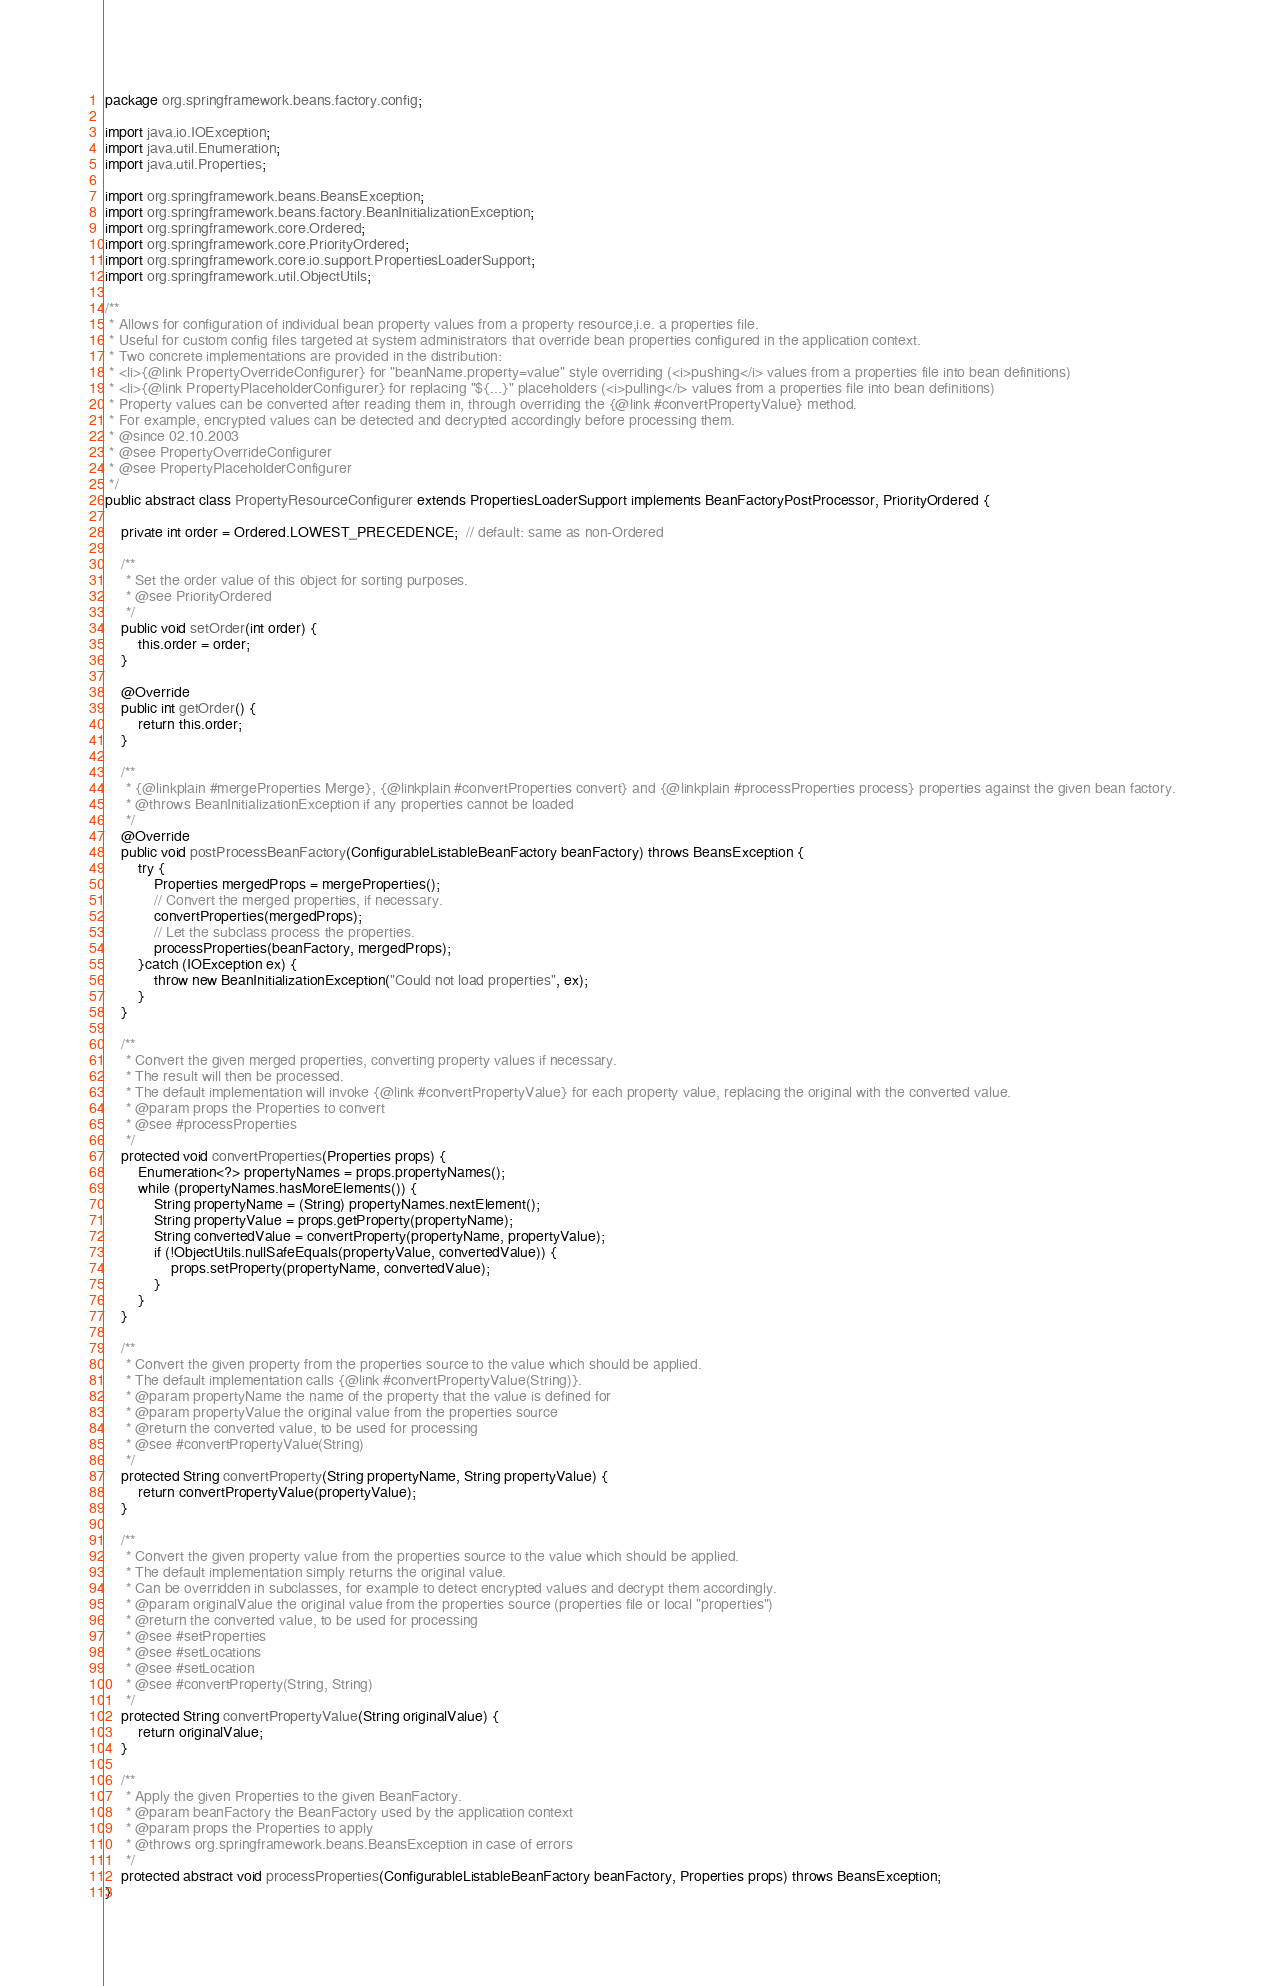Convert code to text. <code><loc_0><loc_0><loc_500><loc_500><_Java_>

package org.springframework.beans.factory.config;

import java.io.IOException;
import java.util.Enumeration;
import java.util.Properties;

import org.springframework.beans.BeansException;
import org.springframework.beans.factory.BeanInitializationException;
import org.springframework.core.Ordered;
import org.springframework.core.PriorityOrdered;
import org.springframework.core.io.support.PropertiesLoaderSupport;
import org.springframework.util.ObjectUtils;

/**
 * Allows for configuration of individual bean property values from a property resource,i.e. a properties file.
 * Useful for custom config files targeted at system administrators that override bean properties configured in the application context.
 * Two concrete implementations are provided in the distribution:
 * <li>{@link PropertyOverrideConfigurer} for "beanName.property=value" style overriding (<i>pushing</i> values from a properties file into bean definitions)
 * <li>{@link PropertyPlaceholderConfigurer} for replacing "${...}" placeholders (<i>pulling</i> values from a properties file into bean definitions)
 * Property values can be converted after reading them in, through overriding the {@link #convertPropertyValue} method.
 * For example, encrypted values can be detected and decrypted accordingly before processing them.
 * @since 02.10.2003
 * @see PropertyOverrideConfigurer
 * @see PropertyPlaceholderConfigurer
 */
public abstract class PropertyResourceConfigurer extends PropertiesLoaderSupport implements BeanFactoryPostProcessor, PriorityOrdered {

	private int order = Ordered.LOWEST_PRECEDENCE;  // default: same as non-Ordered

	/**
	 * Set the order value of this object for sorting purposes.
	 * @see PriorityOrdered
	 */
	public void setOrder(int order) {
		this.order = order;
	}

	@Override
	public int getOrder() {
		return this.order;
	}

	/**
	 * {@linkplain #mergeProperties Merge}, {@linkplain #convertProperties convert} and {@linkplain #processProperties process} properties against the given bean factory.
	 * @throws BeanInitializationException if any properties cannot be loaded
	 */
	@Override
	public void postProcessBeanFactory(ConfigurableListableBeanFactory beanFactory) throws BeansException {
		try {
			Properties mergedProps = mergeProperties();
			// Convert the merged properties, if necessary.
			convertProperties(mergedProps);
			// Let the subclass process the properties.
			processProperties(beanFactory, mergedProps);
		}catch (IOException ex) {
			throw new BeanInitializationException("Could not load properties", ex);
		}
	}

	/**
	 * Convert the given merged properties, converting property values if necessary.
	 * The result will then be processed.
	 * The default implementation will invoke {@link #convertPropertyValue} for each property value, replacing the original with the converted value.
	 * @param props the Properties to convert
	 * @see #processProperties
	 */
	protected void convertProperties(Properties props) {
		Enumeration<?> propertyNames = props.propertyNames();
		while (propertyNames.hasMoreElements()) {
			String propertyName = (String) propertyNames.nextElement();
			String propertyValue = props.getProperty(propertyName);
			String convertedValue = convertProperty(propertyName, propertyValue);
			if (!ObjectUtils.nullSafeEquals(propertyValue, convertedValue)) {
				props.setProperty(propertyName, convertedValue);
			}
		}
	}

	/**
	 * Convert the given property from the properties source to the value which should be applied.
	 * The default implementation calls {@link #convertPropertyValue(String)}.
	 * @param propertyName the name of the property that the value is defined for
	 * @param propertyValue the original value from the properties source
	 * @return the converted value, to be used for processing
	 * @see #convertPropertyValue(String)
	 */
	protected String convertProperty(String propertyName, String propertyValue) {
		return convertPropertyValue(propertyValue);
	}

	/**
	 * Convert the given property value from the properties source to the value which should be applied.
	 * The default implementation simply returns the original value.
	 * Can be overridden in subclasses, for example to detect encrypted values and decrypt them accordingly.
	 * @param originalValue the original value from the properties source (properties file or local "properties")
	 * @return the converted value, to be used for processing
	 * @see #setProperties
	 * @see #setLocations
	 * @see #setLocation
	 * @see #convertProperty(String, String)
	 */
	protected String convertPropertyValue(String originalValue) {
		return originalValue;
	}

	/**
	 * Apply the given Properties to the given BeanFactory.
	 * @param beanFactory the BeanFactory used by the application context
	 * @param props the Properties to apply
	 * @throws org.springframework.beans.BeansException in case of errors
	 */
	protected abstract void processProperties(ConfigurableListableBeanFactory beanFactory, Properties props) throws BeansException;
}
</code> 